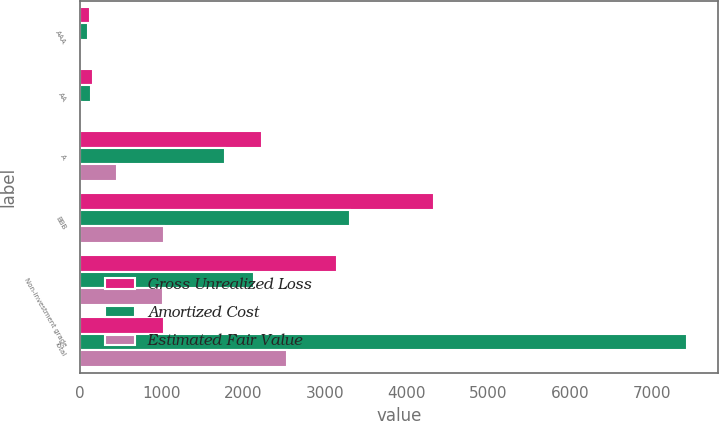Convert chart to OTSL. <chart><loc_0><loc_0><loc_500><loc_500><stacked_bar_chart><ecel><fcel>AAA<fcel>AA<fcel>A<fcel>BBB<fcel>Non-investment grade<fcel>Total<nl><fcel>Gross Unrealized Loss<fcel>116<fcel>156<fcel>2223<fcel>4335<fcel>3144<fcel>1032<nl><fcel>Amortized Cost<fcel>99<fcel>138<fcel>1769<fcel>3303<fcel>2127<fcel>7436<nl><fcel>Estimated Fair Value<fcel>17<fcel>18<fcel>454<fcel>1032<fcel>1017<fcel>2538<nl></chart> 